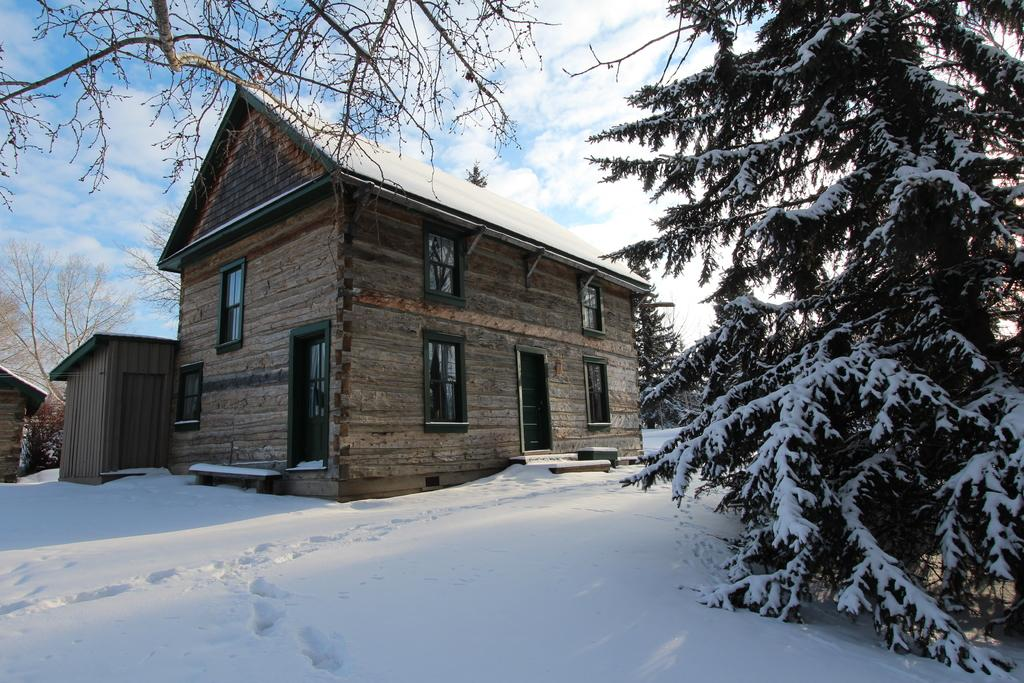What type of structures can be seen in the image? There are houses in the image. What features do the houses have? The houses have windows and doors. What is the weather like in the image? There is snow visible in the image, indicating a cold or wintry climate. What type of vegetation is present in the image? There are trees in the image. What is visible in the sky? The sky is visible in the image, and clouds are present. What type of tin can be seen in the aftermath of the storm in the image? There is no tin or storm present in the image; it features houses, snow, trees, and a sky with clouds. 